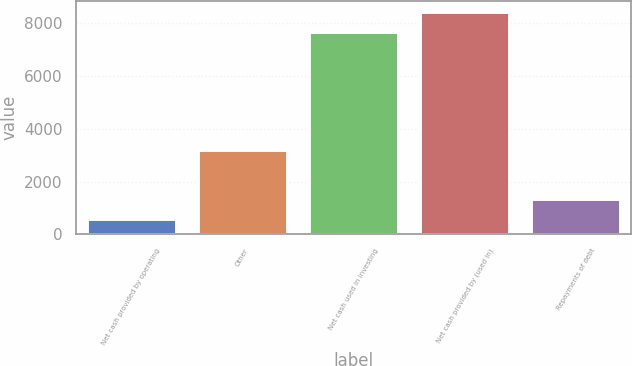<chart> <loc_0><loc_0><loc_500><loc_500><bar_chart><fcel>Net cash provided by operating<fcel>Other<fcel>Net cash used in investing<fcel>Net cash provided by (used in)<fcel>Repayments of debt<nl><fcel>590<fcel>3176<fcel>7643<fcel>8395.9<fcel>1342.9<nl></chart> 